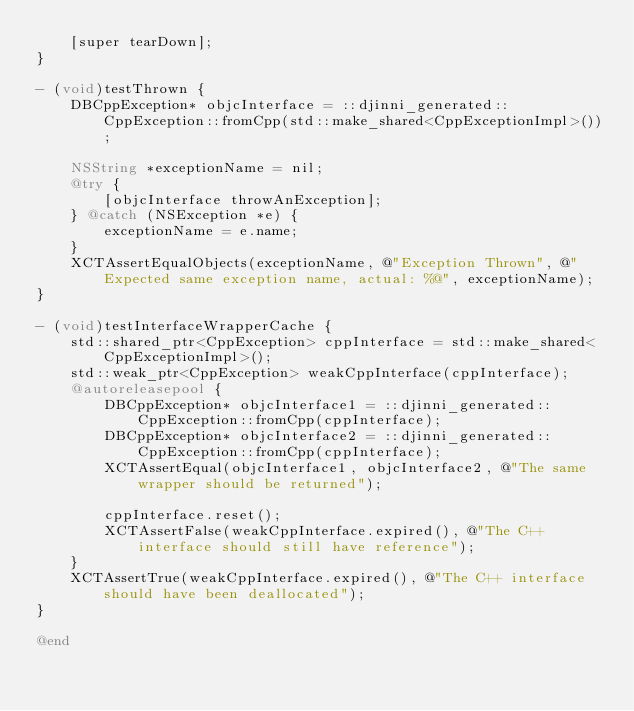Convert code to text. <code><loc_0><loc_0><loc_500><loc_500><_ObjectiveC_>    [super tearDown];
}

- (void)testThrown {
    DBCppException* objcInterface = ::djinni_generated::CppException::fromCpp(std::make_shared<CppExceptionImpl>());

    NSString *exceptionName = nil;
    @try {
        [objcInterface throwAnException];
    } @catch (NSException *e) {
        exceptionName = e.name;
    }
    XCTAssertEqualObjects(exceptionName, @"Exception Thrown", @"Expected same exception name, actual: %@", exceptionName);
}

- (void)testInterfaceWrapperCache {
    std::shared_ptr<CppException> cppInterface = std::make_shared<CppExceptionImpl>();
    std::weak_ptr<CppException> weakCppInterface(cppInterface);
    @autoreleasepool {
        DBCppException* objcInterface1 = ::djinni_generated::CppException::fromCpp(cppInterface);
        DBCppException* objcInterface2 = ::djinni_generated::CppException::fromCpp(cppInterface);
        XCTAssertEqual(objcInterface1, objcInterface2, @"The same wrapper should be returned");

        cppInterface.reset();
        XCTAssertFalse(weakCppInterface.expired(), @"The C++ interface should still have reference");
    }
    XCTAssertTrue(weakCppInterface.expired(), @"The C++ interface should have been deallocated");
}

@end
</code> 